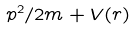<formula> <loc_0><loc_0><loc_500><loc_500>p ^ { 2 } / 2 m + V ( r )</formula> 